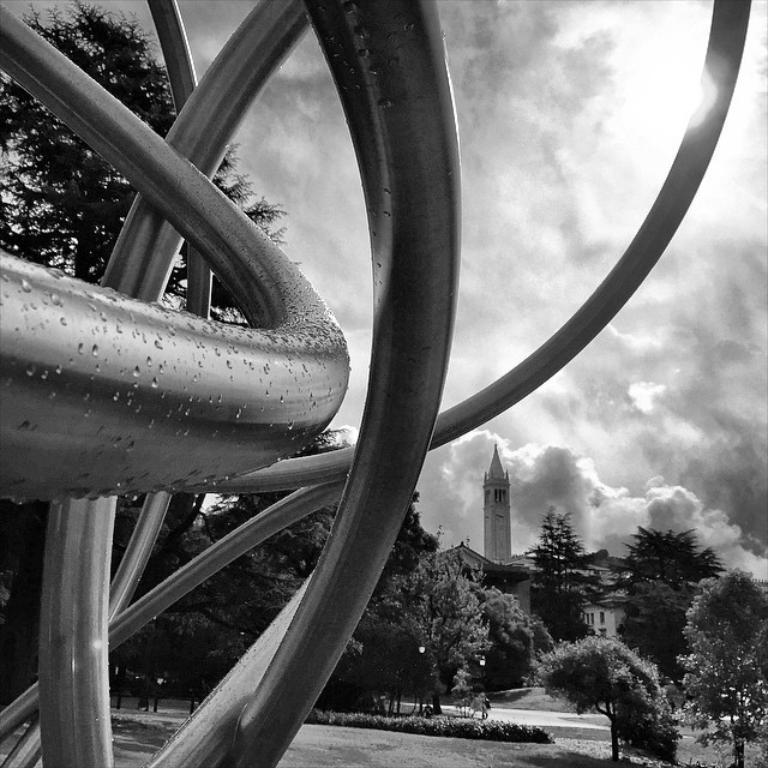What is the color scheme of the image? The image is black and white. What is the main subject in the image? There is a statue of rods in the image. What can be seen in the background of the image? There are trees, buildings, a tower, plants, grass, a walkway, and poles in the background of the image. What is the condition of the sky in the image? The sky is cloudy in the background of the image. Where is the garden located in the image? There is no garden present in the image. What type of stage can be seen in the image? There is no stage present in the image. 